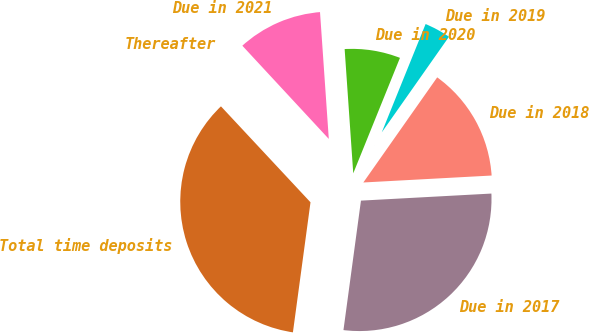Convert chart to OTSL. <chart><loc_0><loc_0><loc_500><loc_500><pie_chart><fcel>Due in 2017<fcel>Due in 2018<fcel>Due in 2019<fcel>Due in 2020<fcel>Due in 2021<fcel>Thereafter<fcel>Total time deposits<nl><fcel>28.0%<fcel>14.39%<fcel>3.63%<fcel>7.22%<fcel>10.8%<fcel>0.05%<fcel>35.91%<nl></chart> 